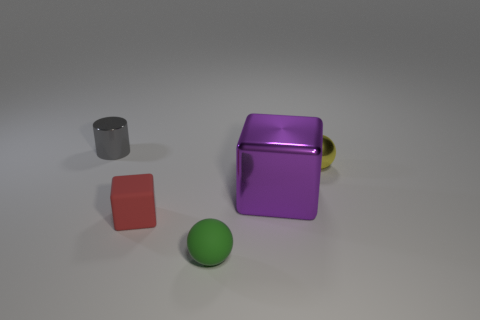What number of gray cylinders are behind the small matte thing that is to the left of the sphere in front of the purple shiny block?
Offer a very short reply. 1. Are there any other things that have the same size as the purple metal thing?
Your response must be concise. No. Do the cylinder and the block that is right of the tiny green ball have the same size?
Your answer should be very brief. No. How many matte balls are there?
Your response must be concise. 1. Is the size of the matte object that is on the left side of the tiny green rubber thing the same as the purple metallic object that is on the left side of the tiny metal ball?
Your response must be concise. No. What is the color of the other rubber thing that is the same shape as the purple object?
Offer a very short reply. Red. Does the large purple metallic thing have the same shape as the red matte thing?
Your answer should be very brief. Yes. There is another object that is the same shape as the large purple metallic object; what size is it?
Provide a succinct answer. Small. What number of tiny balls have the same material as the red object?
Give a very brief answer. 1. What number of objects are either large blue metal blocks or small gray cylinders?
Give a very brief answer. 1. 